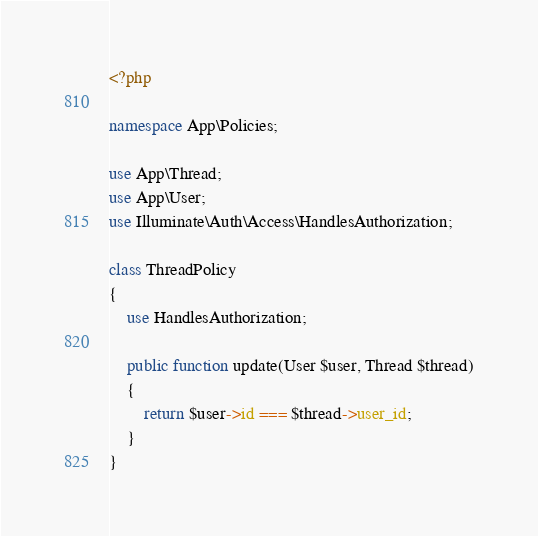Convert code to text. <code><loc_0><loc_0><loc_500><loc_500><_PHP_><?php

namespace App\Policies;

use App\Thread;
use App\User;
use Illuminate\Auth\Access\HandlesAuthorization;

class ThreadPolicy
{
    use HandlesAuthorization;

    public function update(User $user, Thread $thread)
    {
        return $user->id === $thread->user_id;
    }
}
</code> 